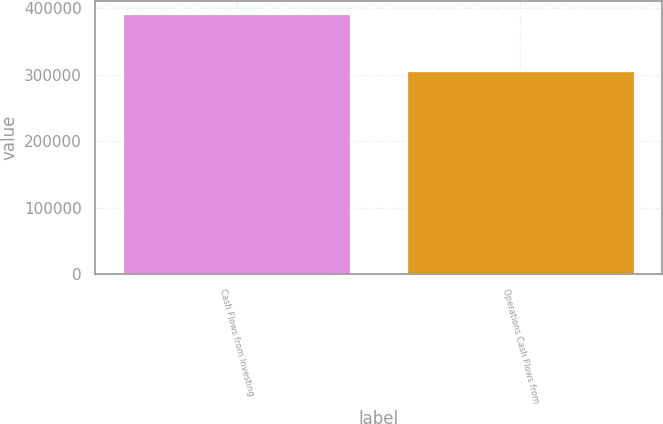<chart> <loc_0><loc_0><loc_500><loc_500><bar_chart><fcel>Cash Flows from Investing<fcel>Operations Cash Flows from<nl><fcel>391696<fcel>306175<nl></chart> 